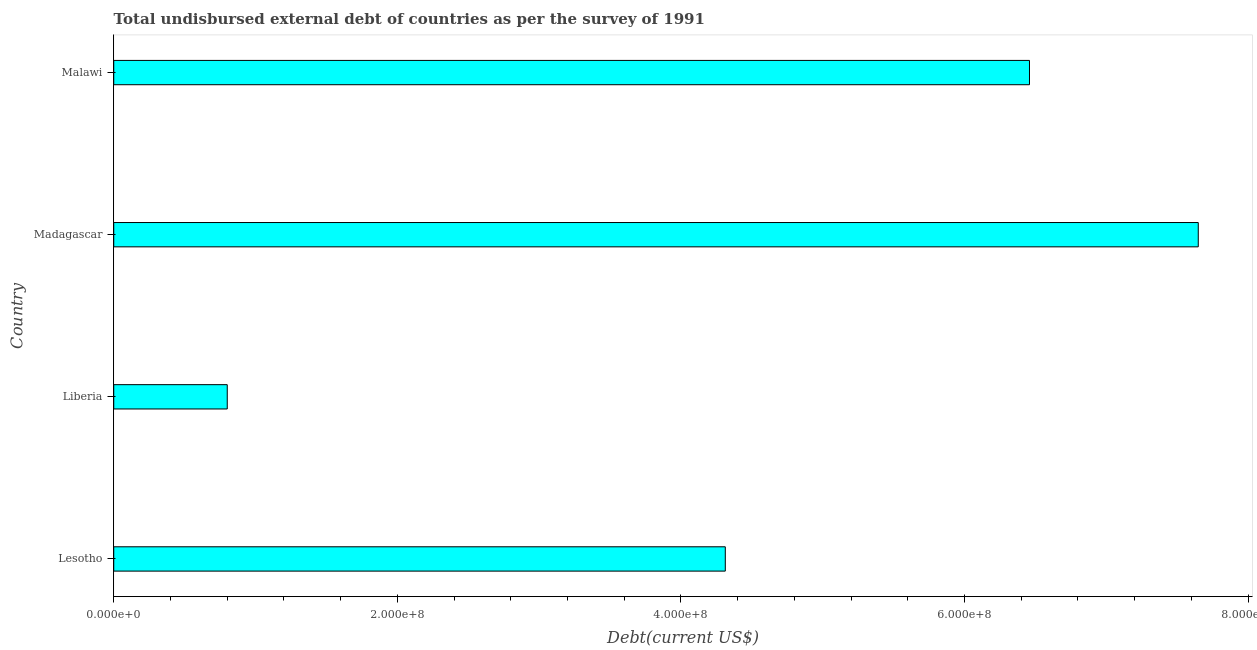What is the title of the graph?
Keep it short and to the point. Total undisbursed external debt of countries as per the survey of 1991. What is the label or title of the X-axis?
Your response must be concise. Debt(current US$). What is the label or title of the Y-axis?
Make the answer very short. Country. What is the total debt in Liberia?
Give a very brief answer. 8.01e+07. Across all countries, what is the maximum total debt?
Ensure brevity in your answer.  7.65e+08. Across all countries, what is the minimum total debt?
Offer a very short reply. 8.01e+07. In which country was the total debt maximum?
Give a very brief answer. Madagascar. In which country was the total debt minimum?
Offer a very short reply. Liberia. What is the sum of the total debt?
Ensure brevity in your answer.  1.92e+09. What is the difference between the total debt in Liberia and Madagascar?
Make the answer very short. -6.85e+08. What is the average total debt per country?
Your answer should be very brief. 4.80e+08. What is the median total debt?
Provide a short and direct response. 5.39e+08. In how many countries, is the total debt greater than 440000000 US$?
Keep it short and to the point. 2. What is the ratio of the total debt in Lesotho to that in Liberia?
Your response must be concise. 5.39. Is the total debt in Lesotho less than that in Liberia?
Provide a short and direct response. No. Is the difference between the total debt in Lesotho and Madagascar greater than the difference between any two countries?
Keep it short and to the point. No. What is the difference between the highest and the second highest total debt?
Keep it short and to the point. 1.19e+08. What is the difference between the highest and the lowest total debt?
Make the answer very short. 6.85e+08. In how many countries, is the total debt greater than the average total debt taken over all countries?
Keep it short and to the point. 2. Are all the bars in the graph horizontal?
Make the answer very short. Yes. How many countries are there in the graph?
Your answer should be very brief. 4. What is the difference between two consecutive major ticks on the X-axis?
Keep it short and to the point. 2.00e+08. What is the Debt(current US$) in Lesotho?
Provide a succinct answer. 4.31e+08. What is the Debt(current US$) in Liberia?
Give a very brief answer. 8.01e+07. What is the Debt(current US$) of Madagascar?
Your answer should be compact. 7.65e+08. What is the Debt(current US$) in Malawi?
Offer a terse response. 6.46e+08. What is the difference between the Debt(current US$) in Lesotho and Liberia?
Your response must be concise. 3.51e+08. What is the difference between the Debt(current US$) in Lesotho and Madagascar?
Your response must be concise. -3.34e+08. What is the difference between the Debt(current US$) in Lesotho and Malawi?
Offer a terse response. -2.15e+08. What is the difference between the Debt(current US$) in Liberia and Madagascar?
Keep it short and to the point. -6.85e+08. What is the difference between the Debt(current US$) in Liberia and Malawi?
Give a very brief answer. -5.66e+08. What is the difference between the Debt(current US$) in Madagascar and Malawi?
Your response must be concise. 1.19e+08. What is the ratio of the Debt(current US$) in Lesotho to that in Liberia?
Ensure brevity in your answer.  5.39. What is the ratio of the Debt(current US$) in Lesotho to that in Madagascar?
Ensure brevity in your answer.  0.56. What is the ratio of the Debt(current US$) in Lesotho to that in Malawi?
Provide a succinct answer. 0.67. What is the ratio of the Debt(current US$) in Liberia to that in Madagascar?
Give a very brief answer. 0.1. What is the ratio of the Debt(current US$) in Liberia to that in Malawi?
Ensure brevity in your answer.  0.12. What is the ratio of the Debt(current US$) in Madagascar to that in Malawi?
Provide a succinct answer. 1.18. 